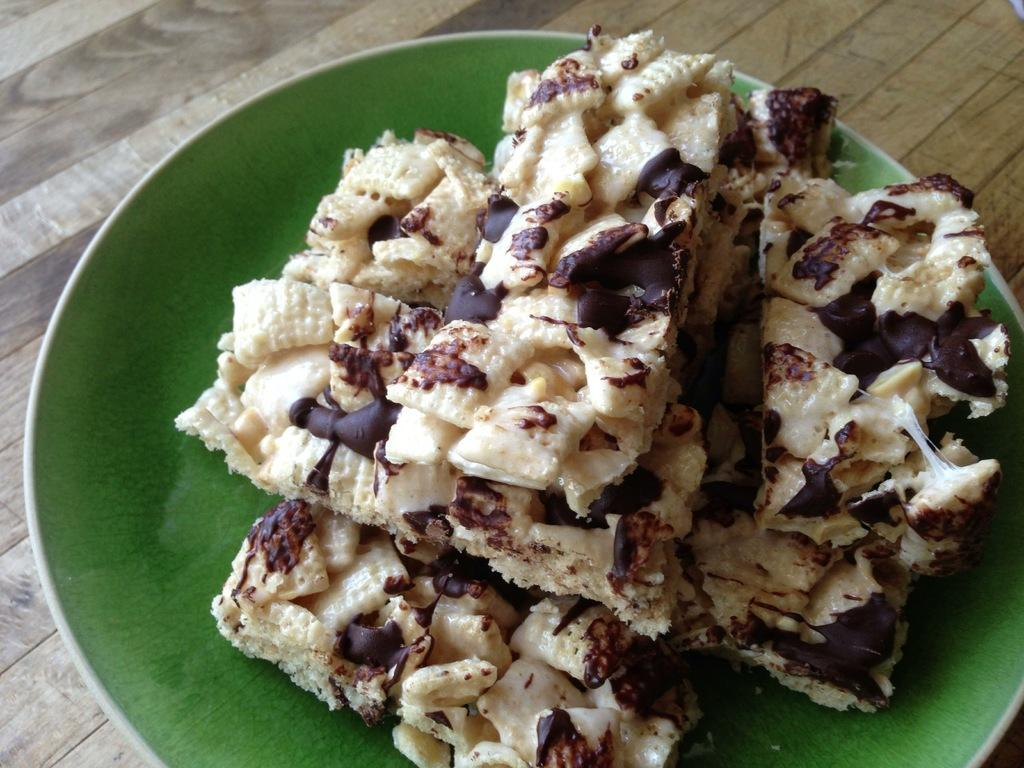What piece of furniture is present in the image? There is a table in the image. What is placed on the table? There is a plate on the table. What can be found on the plate? There is a food item on the plate. What is the size of the bit in the image? There is no bit present in the image, so it is not possible to determine its size. 